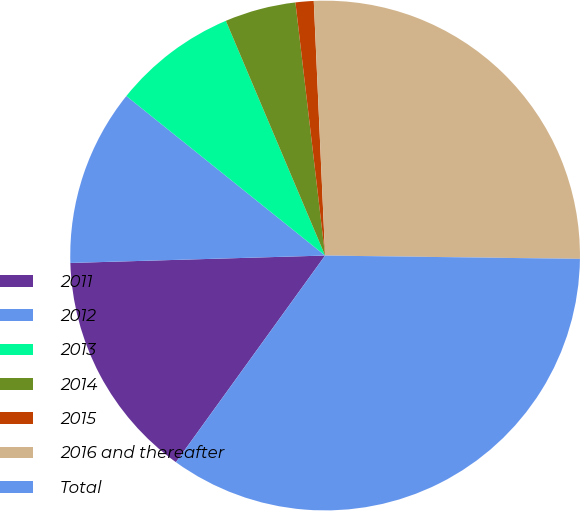<chart> <loc_0><loc_0><loc_500><loc_500><pie_chart><fcel>2011<fcel>2012<fcel>2013<fcel>2014<fcel>2015<fcel>2016 and thereafter<fcel>Total<nl><fcel>14.59%<fcel>11.23%<fcel>7.87%<fcel>4.51%<fcel>1.15%<fcel>25.92%<fcel>34.75%<nl></chart> 